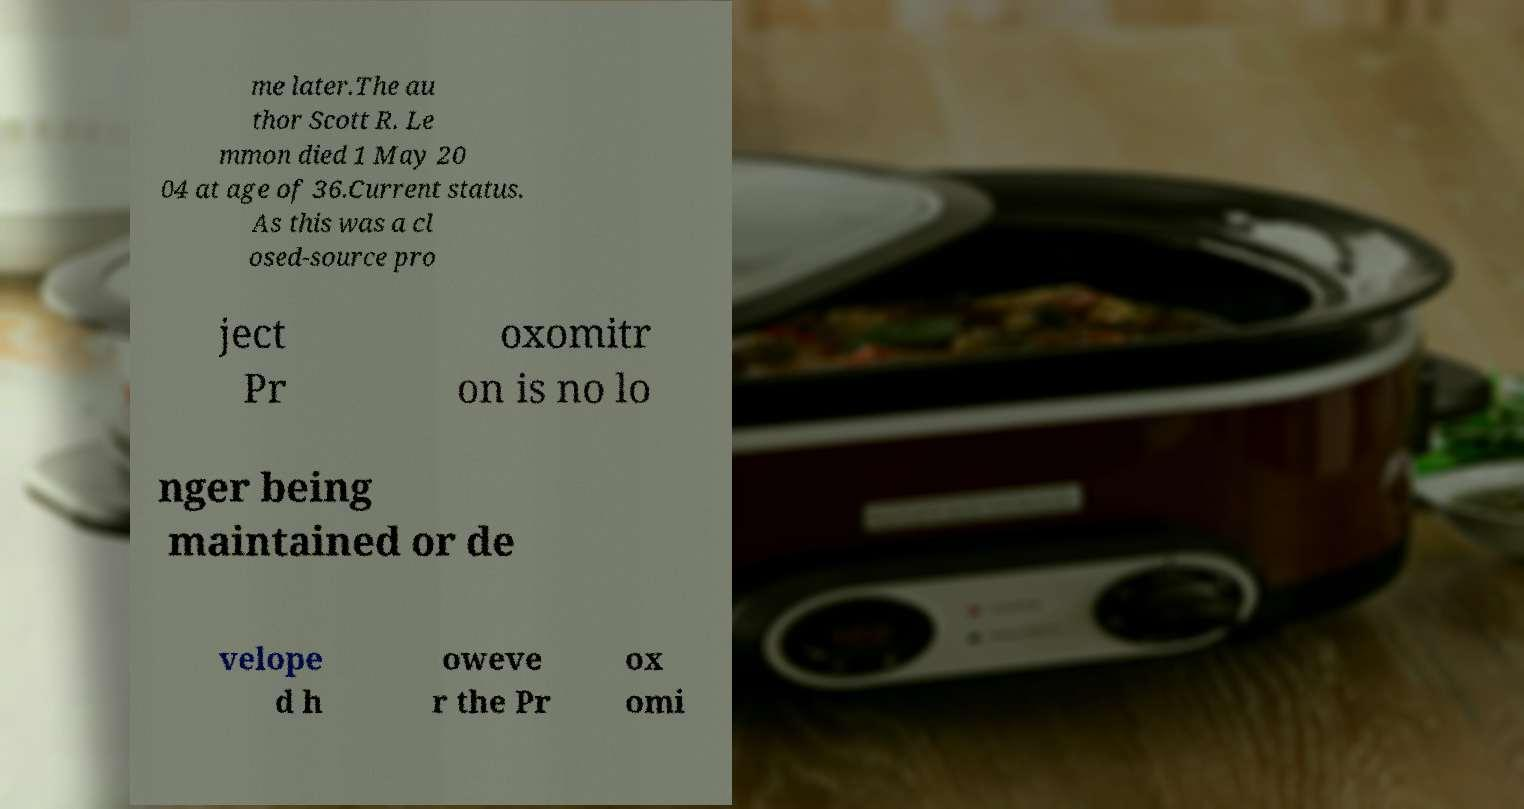Can you read and provide the text displayed in the image?This photo seems to have some interesting text. Can you extract and type it out for me? me later.The au thor Scott R. Le mmon died 1 May 20 04 at age of 36.Current status. As this was a cl osed-source pro ject Pr oxomitr on is no lo nger being maintained or de velope d h oweve r the Pr ox omi 